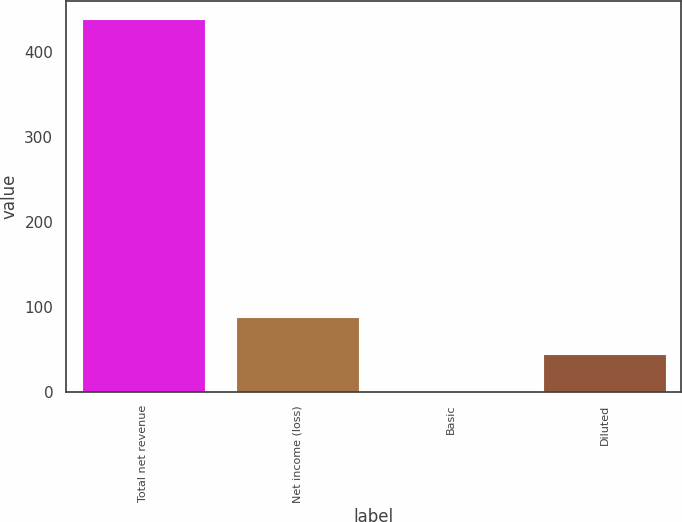Convert chart to OTSL. <chart><loc_0><loc_0><loc_500><loc_500><bar_chart><fcel>Total net revenue<fcel>Net income (loss)<fcel>Basic<fcel>Diluted<nl><fcel>438<fcel>87.8<fcel>0.24<fcel>44.02<nl></chart> 